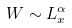<formula> <loc_0><loc_0><loc_500><loc_500>W \sim L _ { x } ^ { \alpha }</formula> 